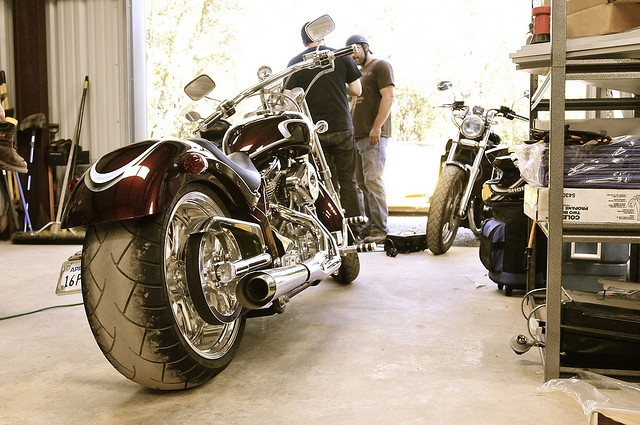Describe the objects in this image and their specific colors. I can see motorcycle in gray, black, white, olive, and tan tones, people in gray, black, and white tones, motorcycle in gray, white, black, olive, and tan tones, and people in gray and black tones in this image. 